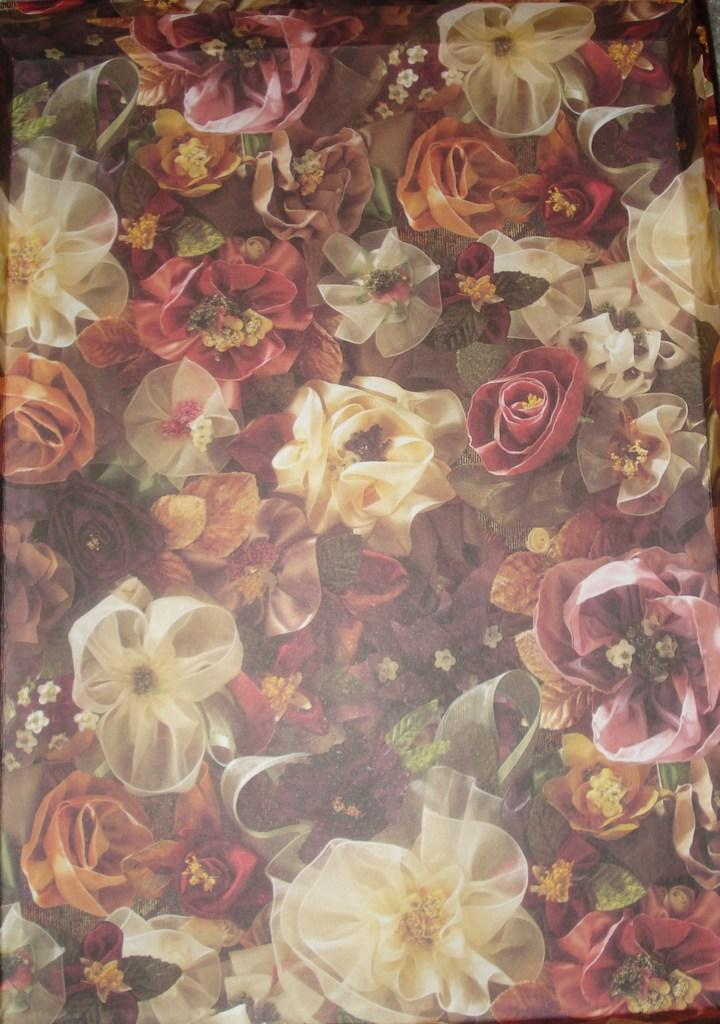What is present in the image? There is a paper in the image. What design or pattern is on the paper? The paper has flowers printed on it. What type of lead can be seen on the paper in the image? There is no lead present on the paper in the image; it has flowers printed on it. 